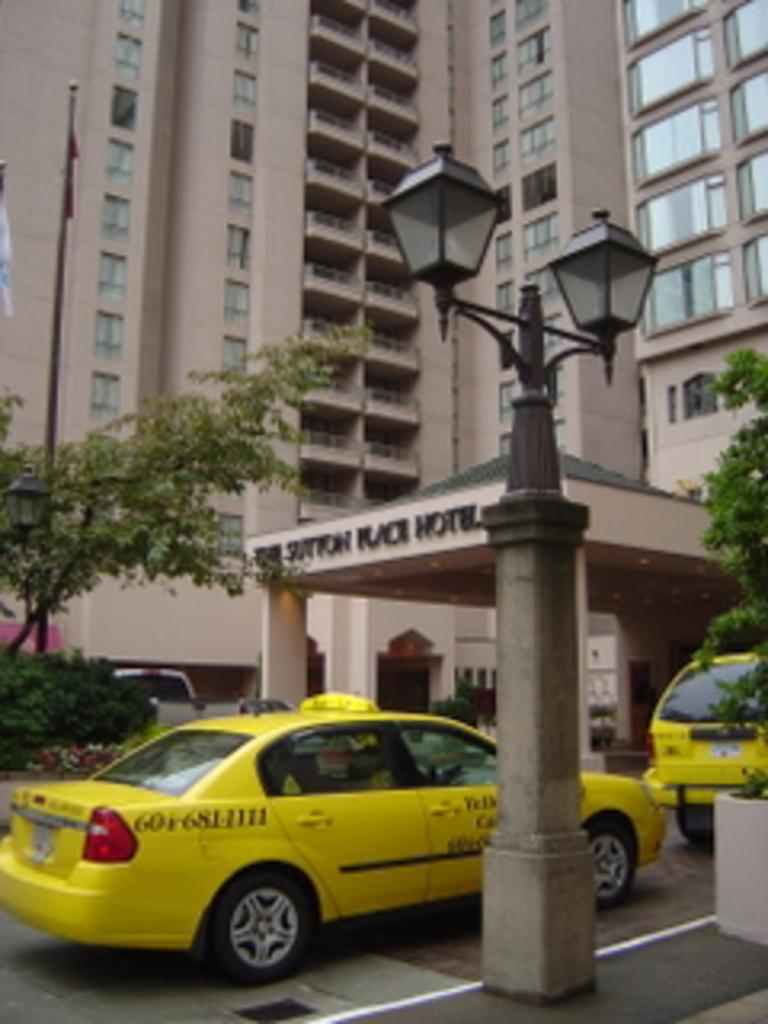<image>
Render a clear and concise summary of the photo. The end of the phone number for the taxi pulling up to the hotel is 1111. 